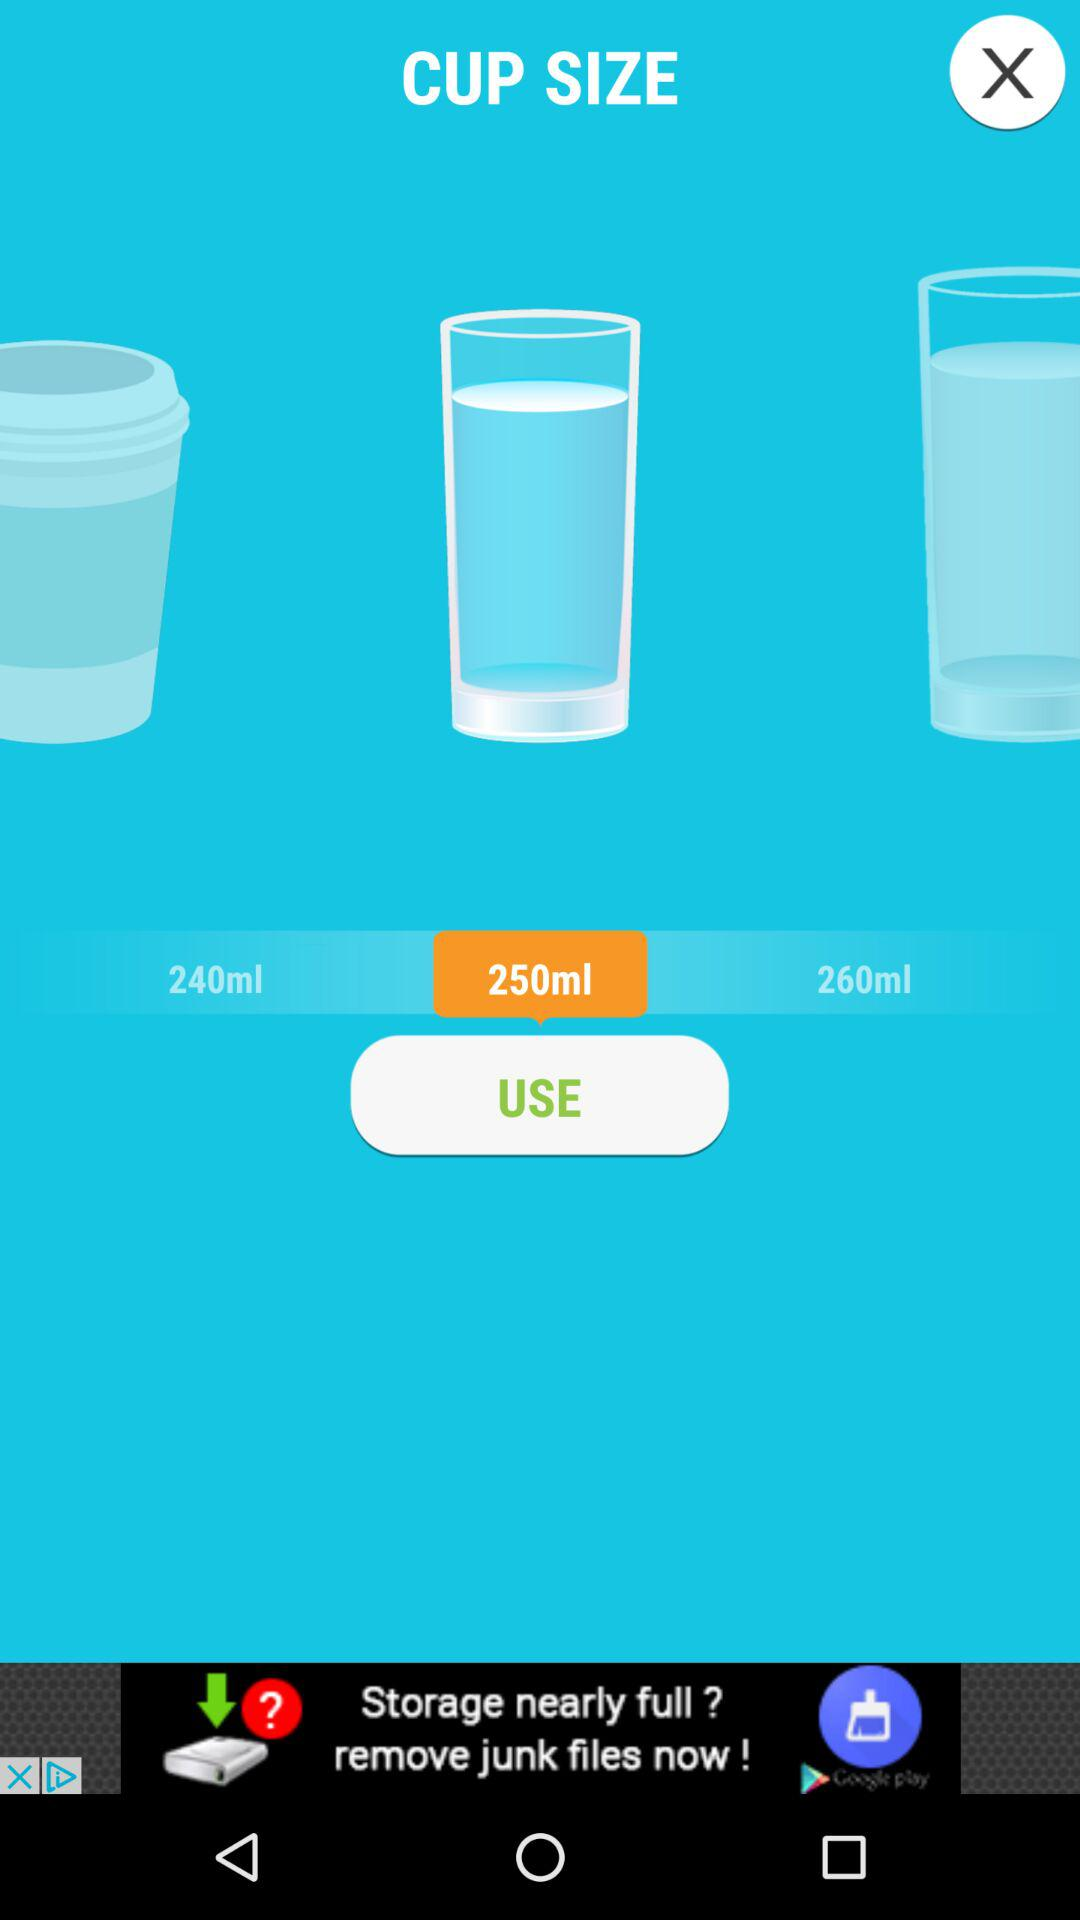What is the selected cup size in ounces?
When the provided information is insufficient, respond with <no answer>. <no answer> 